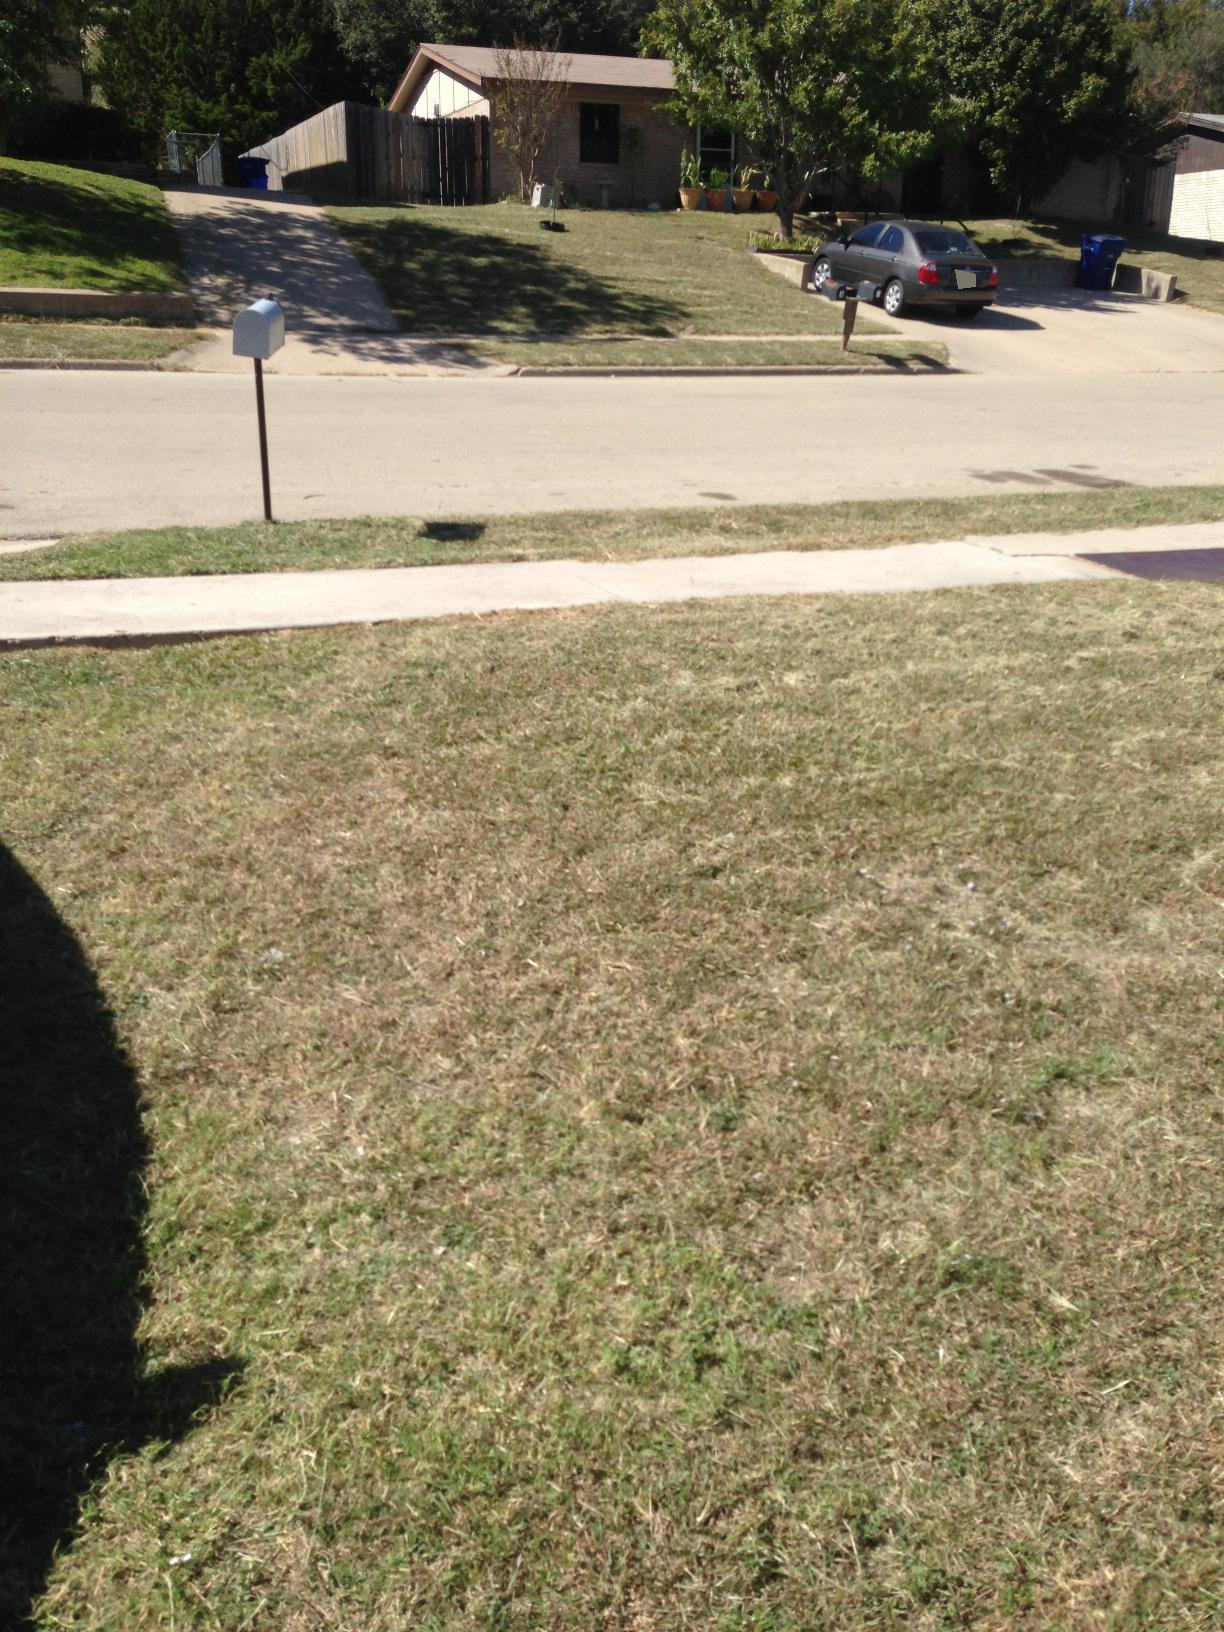What are some prominent objects you see in the image? In this image, some prominent objects include a white mailbox, a car parked in a driveway, a suburban house with a brown roof, and a few trees dotting the landscape. Can you describe the surroundings in detail? Absolutely! The image depicts a tranquil suburban neighborhood. In the foreground, a neatly trimmed grassy lawn stretches out. The street, which appears relatively quiet and free of traffic, runs horizontally across the photo. Opposite the street, a modest house is visible with a brown roof, beige walls, and a couple of potted plants on the front lawn. The driveway slopes up to a wooden fence that partially encloses the property, and parked within the driveway is a silver sedan. Trees sprinkled around add a natural touch to the suburban setting. 